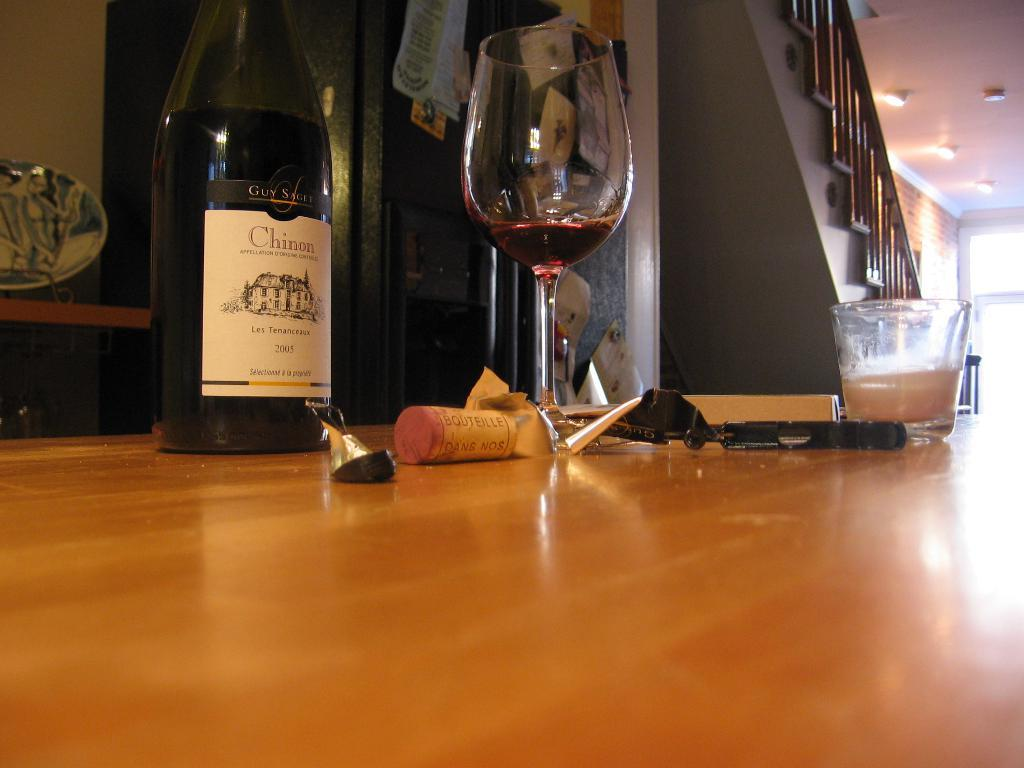What type of furniture is present in the image? There is a table in the image. What can be seen on the table? The table has a bottle and a glass on it, as well as other objects. What architectural feature is visible in the image? There is a staircase in the image. Where is the window located in the image? The window is in the right corner of the image. How many horses are visible in the image? There are no horses present in the image. What type of comb is used to style the hair of the person in the image? There is no person or hair in the image, so it is not possible to determine what type of comb might be used. 